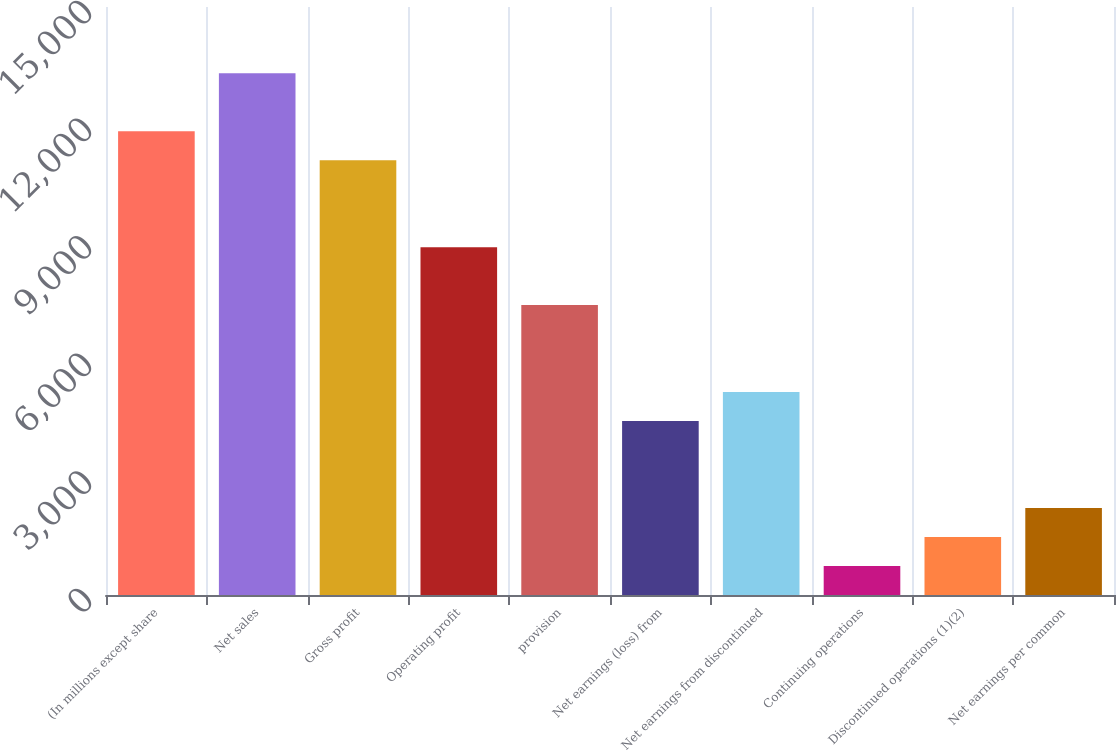Convert chart. <chart><loc_0><loc_0><loc_500><loc_500><bar_chart><fcel>(In millions except share<fcel>Net sales<fcel>Gross profit<fcel>Operating profit<fcel>provision<fcel>Net earnings (loss) from<fcel>Net earnings from discontinued<fcel>Continuing operations<fcel>Discontinued operations (1)(2)<fcel>Net earnings per common<nl><fcel>11831.9<fcel>13310.8<fcel>11092.4<fcel>8874.04<fcel>7395.12<fcel>4437.28<fcel>5176.74<fcel>739.98<fcel>1479.44<fcel>2218.9<nl></chart> 